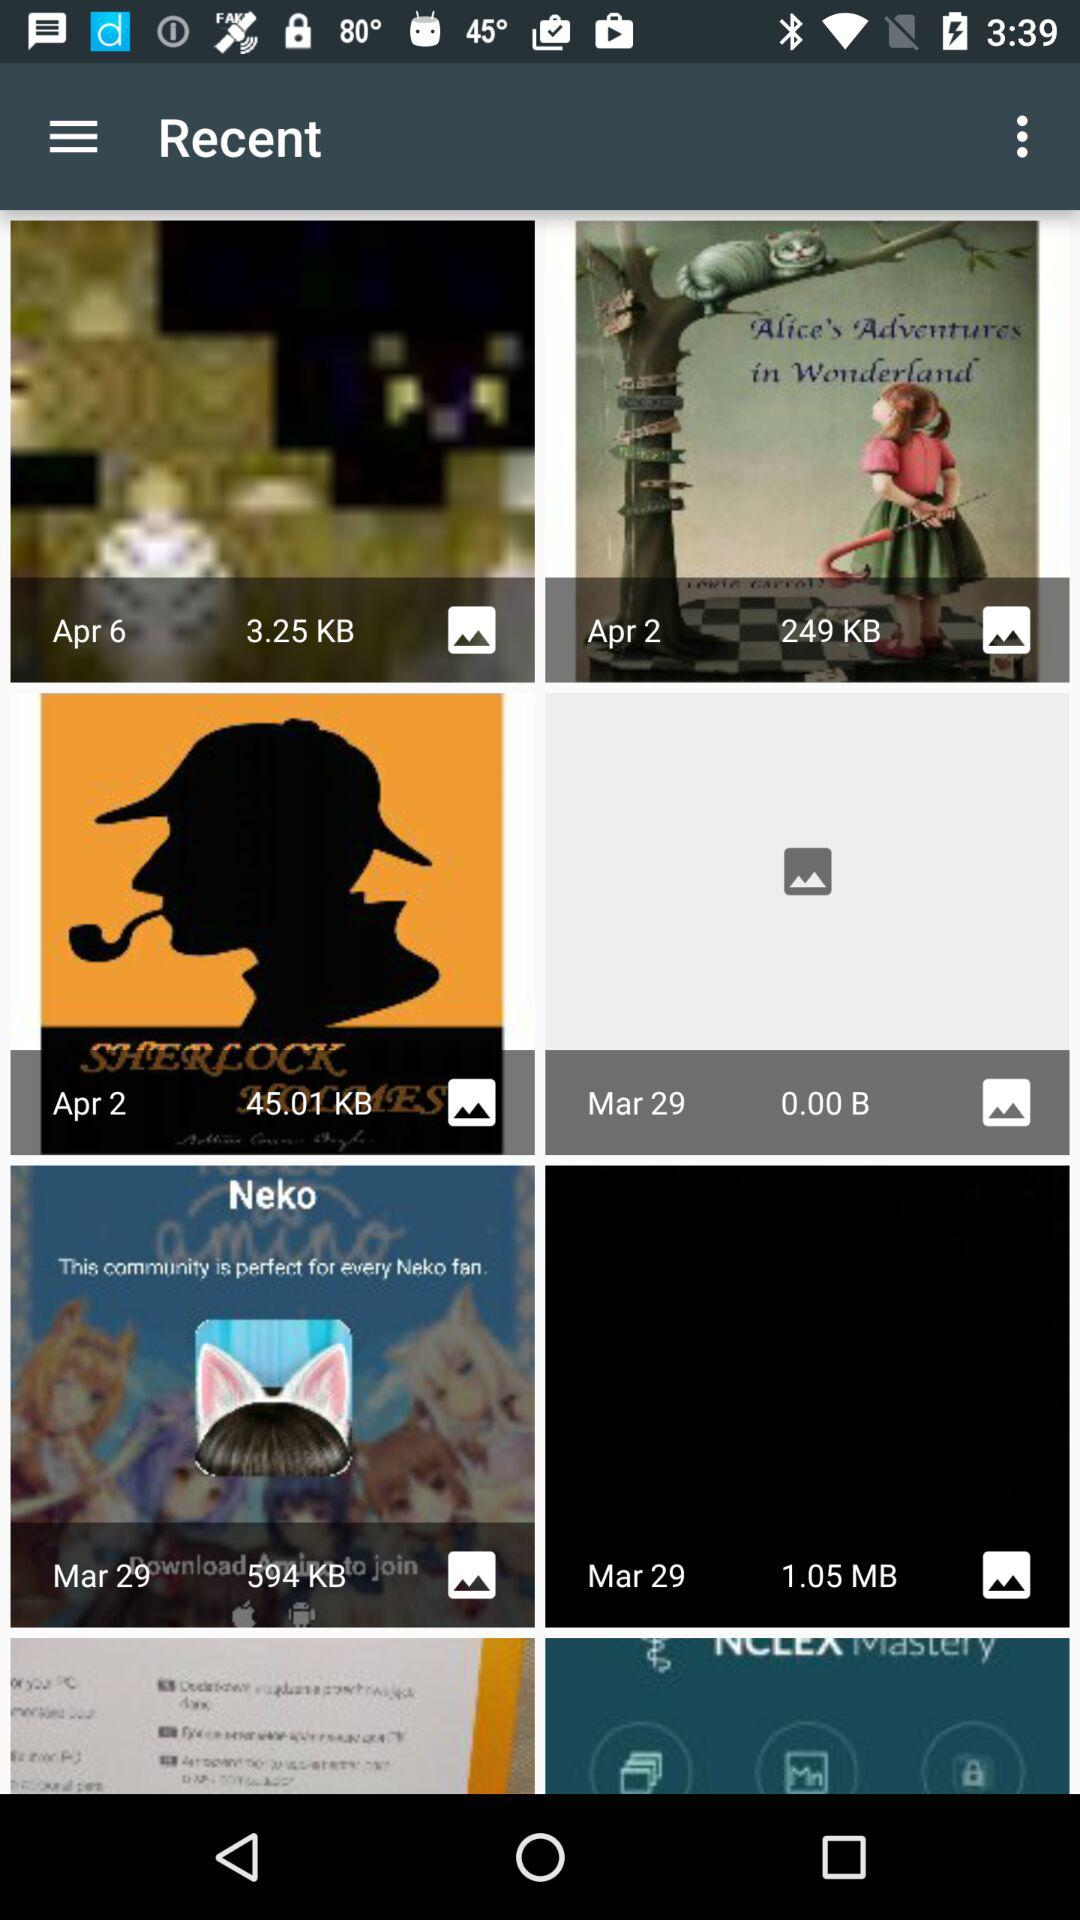How many items have a date of April 2?
Answer the question using a single word or phrase. 2 